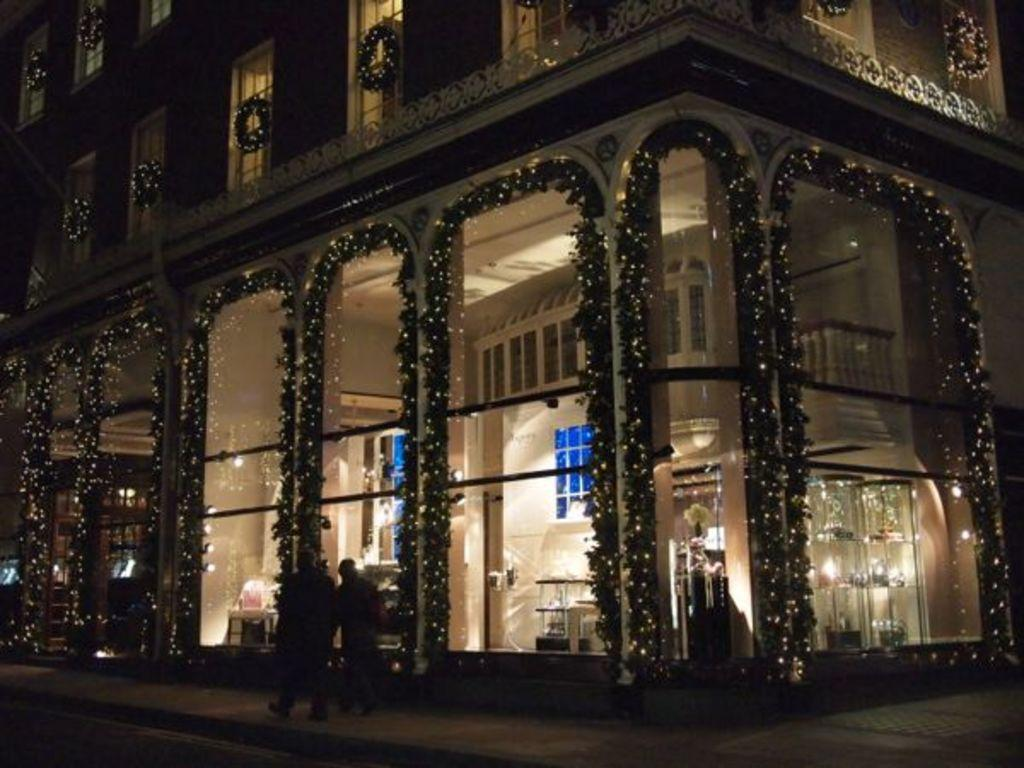What is the main structure in the image? There is a building in the image. How is the building visually enhanced in the image? The building is beautifully decorated with lights. Are there any people present in the image? Yes, there are two people walking on the footpath in front of the building. Can you see a girl experiencing pain in the image? There is no girl or any indication of pain in the image. Are there any bubbles floating around the building in the image? There are no bubbles present in the image. 